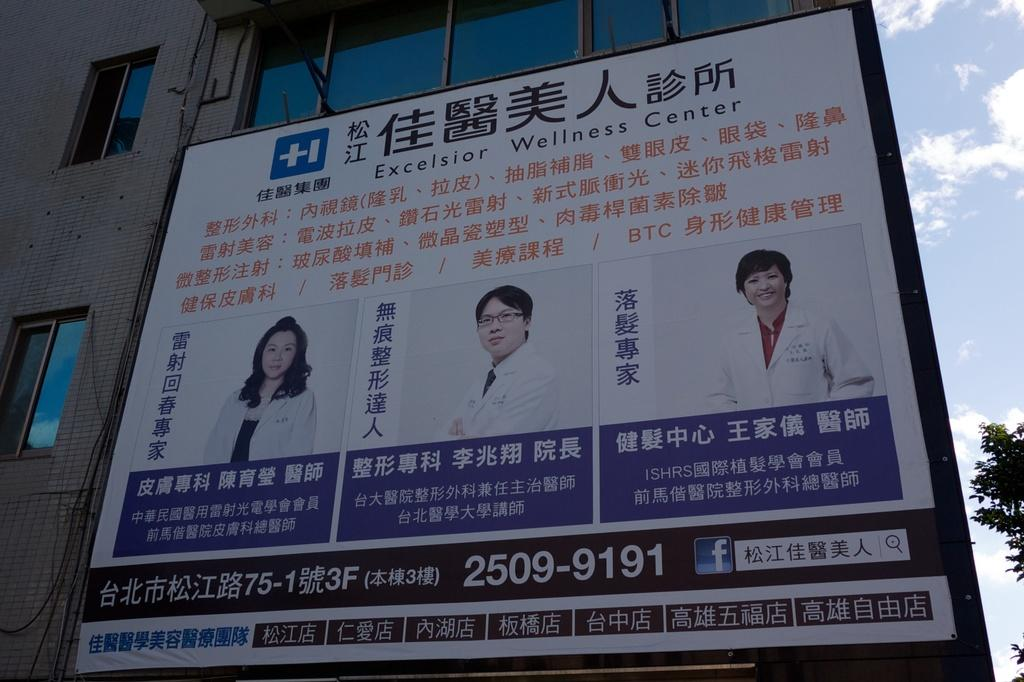<image>
Present a compact description of the photo's key features. A sign for Excelsior Wellness Center features three photos of medical professionals. 